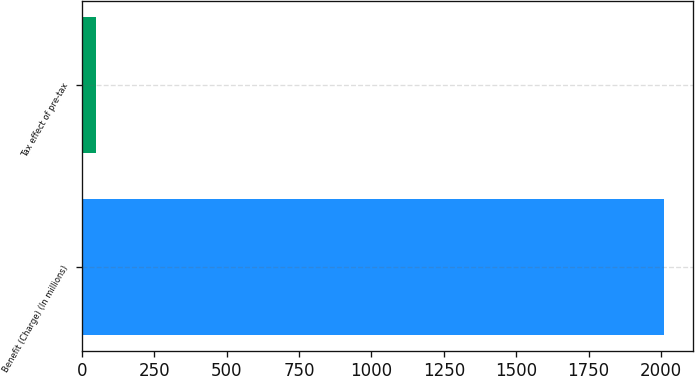Convert chart. <chart><loc_0><loc_0><loc_500><loc_500><bar_chart><fcel>Benefit (Charge) (In millions)<fcel>Tax effect of pre-tax<nl><fcel>2011<fcel>50<nl></chart> 